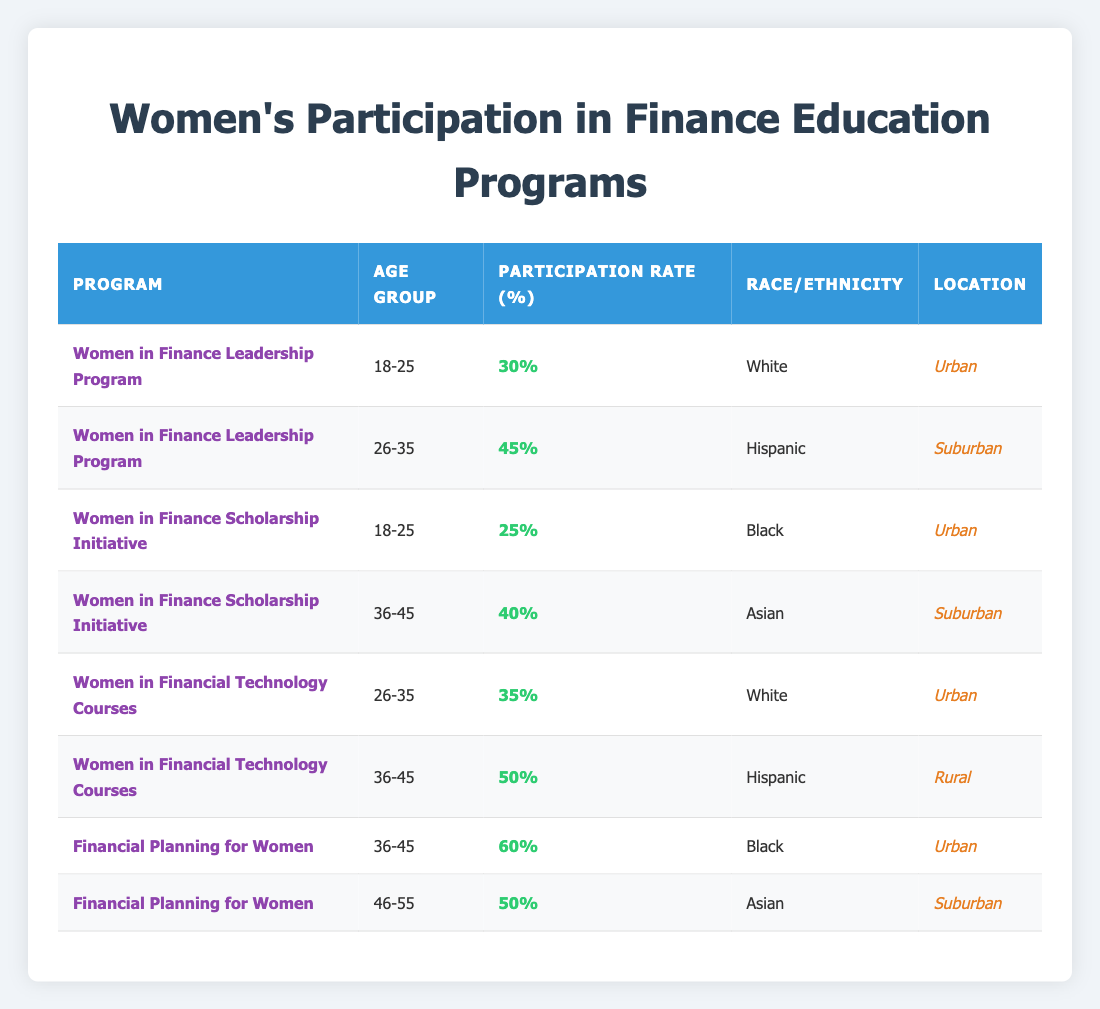What is the participation rate for the Women in Finance Leadership Program for the age group 18-25? The table shows the participation rate for the Women in Finance Leadership Program in the age group 18-25 as 30%.
Answer: 30% What is the highest participation rate observed in any program? The highest participation rate listed in the table is 60%, which corresponds to the Financial Planning for Women program for the age group 36-45.
Answer: 60% Are there any programs in which Hispanic women have a participation rate above 45%? In the table, the Women in Financial Technology Courses program has a participation rate of 50% for Hispanic women in the 36-45 age group, which is above 45%.
Answer: Yes What is the average participation rate for the age group 36-45 across all programs? The participation rates for the age group 36-45 are 40% (Women in Finance Scholarship Initiative), 60% (Financial Planning for Women), and 50% (Women in Financial Technology Courses). Summing these values gives 40 + 60 + 50 = 150, and dividing by the number of programs (3) gives an average of 150/3 = 50%.
Answer: 50% Do women in urban locations have a higher average participation rate than those in suburban locations? The participation rates for urban locations are 30%, 25%, 60%, and 35%, averaging to (30 + 25 + 60 + 35) / 4 = 37.5%. For suburban locations, the rates are 45%, 40%, and 50%, averaging to (45 + 40 + 50) / 3 = 45%. Since 37.5% is less than 45%, women in suburban locations do have a higher average participation rate.
Answer: No What is the participation rate difference between the Women in Financial Technology Courses for age group 26-35 and the Financial Planning for Women for age group 46-55? The participation rate for the Women in Financial Technology Courses for age group 26-35 is 35%, and for Financial Planning for Women for age group 46-55, it is 50%. The difference is 50 - 35 = 15%.
Answer: 15% In which program and age group do Black women have the highest participation rate? Looking at the table, Black women have the highest participation rate (60%) in the Financial Planning for Women program for the age group 36-45.
Answer: Financial Planning for Women, 36-45 Are there any rural programs listed in the table? The table shows one program in rural location, which is Women in Financial Technology Courses for the age group 36-45 with a participation rate of 50%.
Answer: Yes 